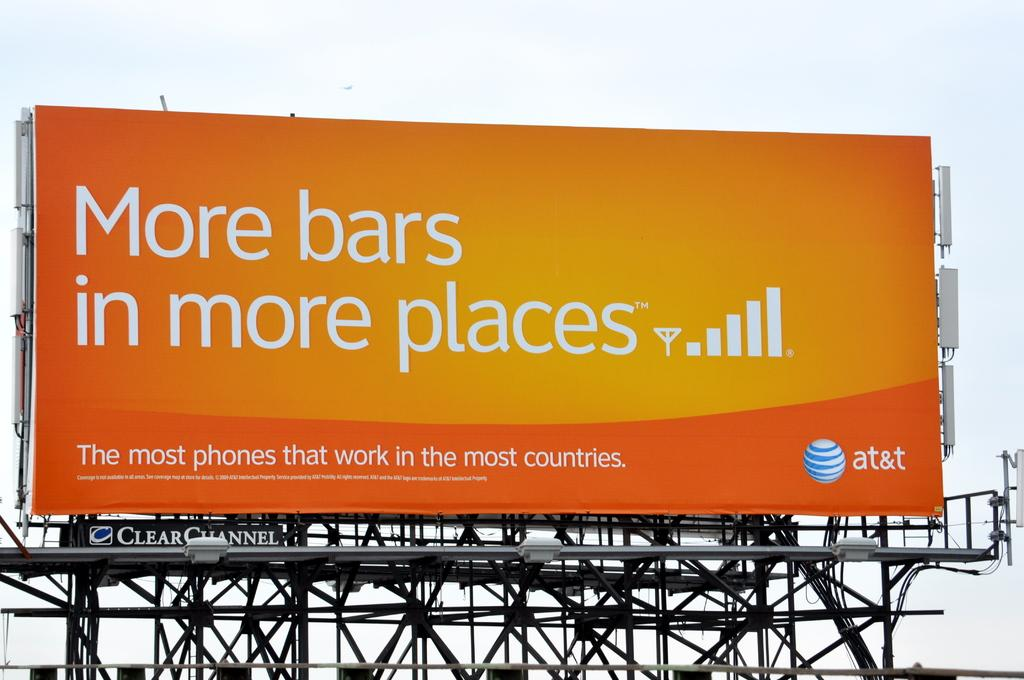<image>
Give a short and clear explanation of the subsequent image. A billboard advertisement by AT&T that says more bars in more places 